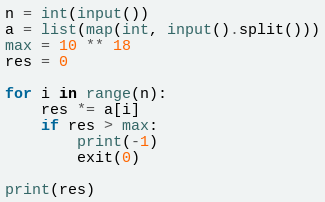Convert code to text. <code><loc_0><loc_0><loc_500><loc_500><_Python_>n = int(input())
a = list(map(int, input().split()))
max = 10 ** 18
res = 0

for i in range(n):
    res *= a[i]
    if res > max:
        print(-1)
        exit(0)

print(res)</code> 